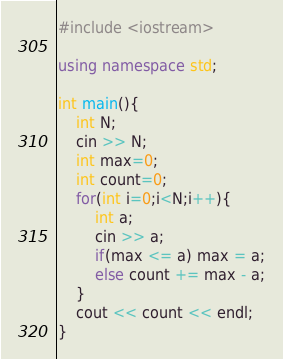<code> <loc_0><loc_0><loc_500><loc_500><_C++_>#include <iostream>

using namespace std;

int main(){
  	int N;
  	cin >> N;
  	int max=0;
  	int count=0;
  	for(int i=0;i<N;i++){	
      	int a;
      	cin >> a;
      	if(max <= a) max = a;
      	else count += max - a;
    }
  	cout << count << endl;
}</code> 